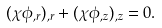<formula> <loc_0><loc_0><loc_500><loc_500>( \chi \phi _ { , r } ) _ { , r } + ( \chi \phi _ { , z } ) _ { , z } = 0 .</formula> 